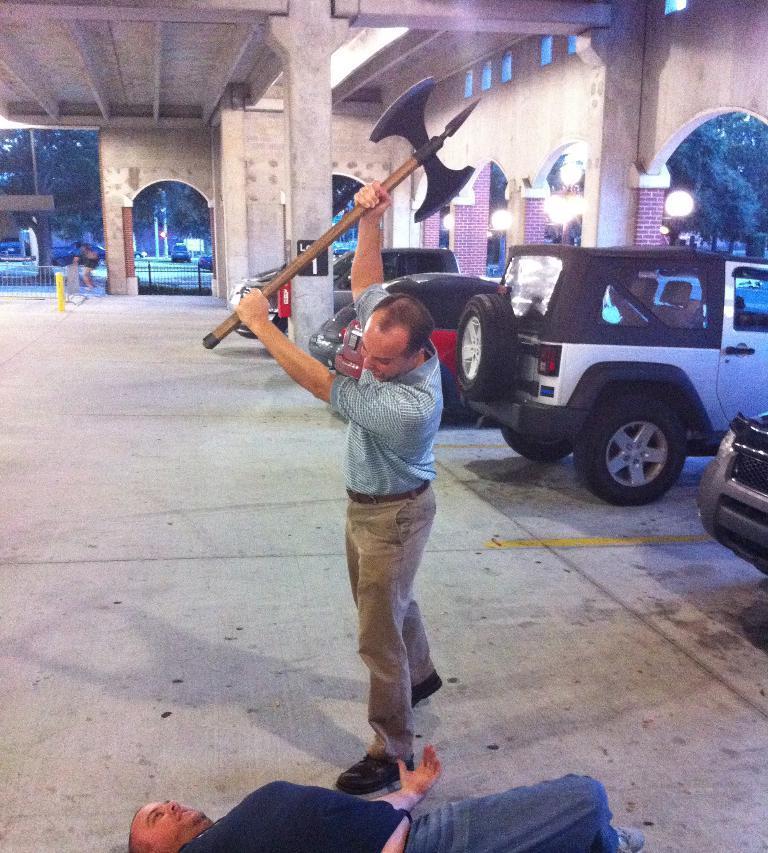Can you describe this image briefly? In the picture I can see two men among them one man is standing and holding something in the hand and other is lying on the ground. In the background I can see a person, trees, pillars, wall, lights, vehicles, fence and some other things. 